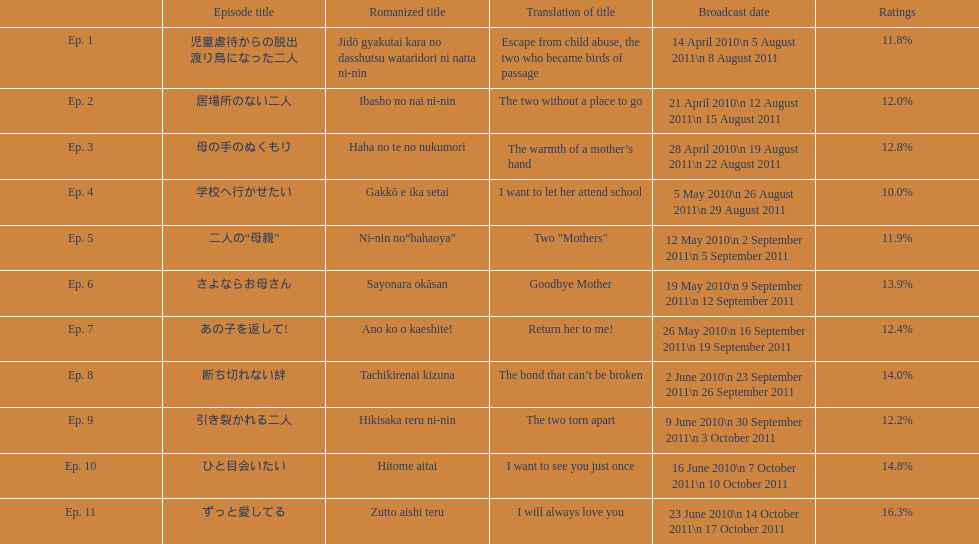How many episodes are listed? 11. 